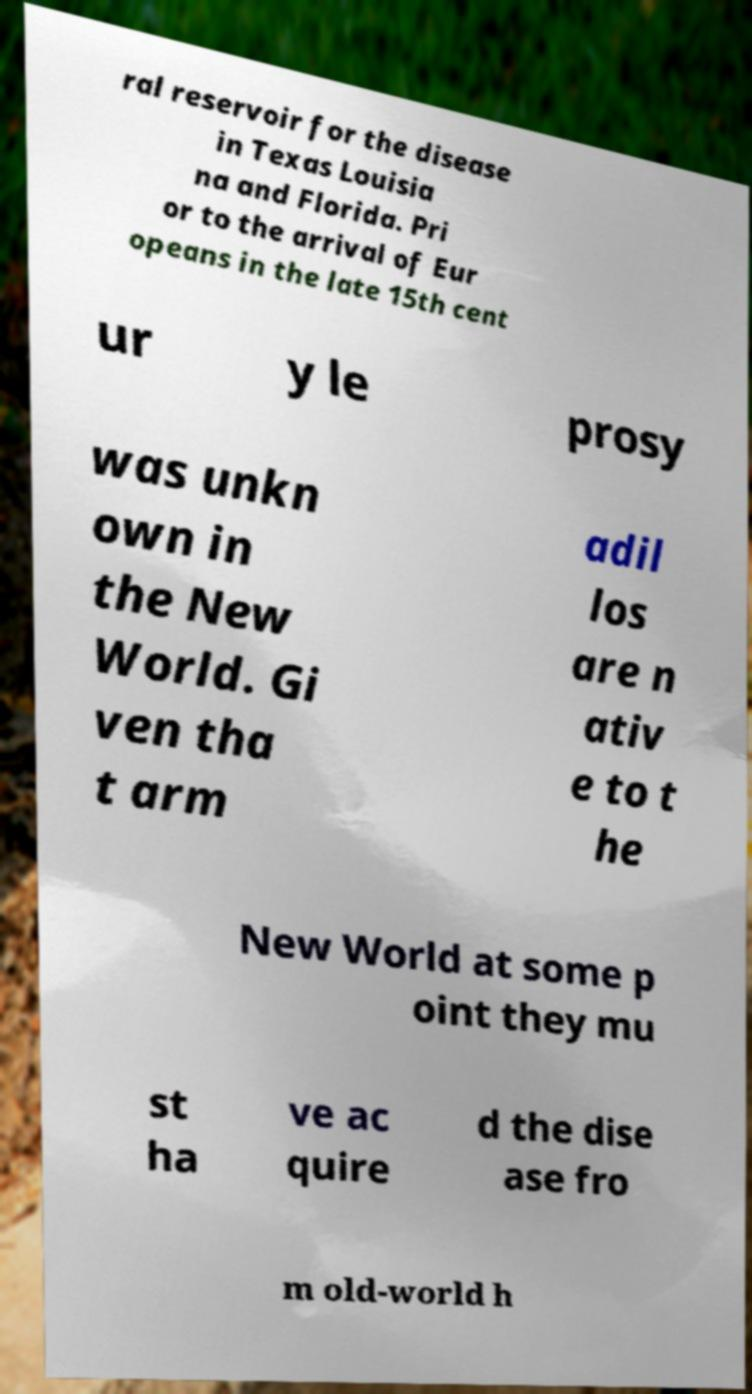Please identify and transcribe the text found in this image. ral reservoir for the disease in Texas Louisia na and Florida. Pri or to the arrival of Eur opeans in the late 15th cent ur y le prosy was unkn own in the New World. Gi ven tha t arm adil los are n ativ e to t he New World at some p oint they mu st ha ve ac quire d the dise ase fro m old-world h 